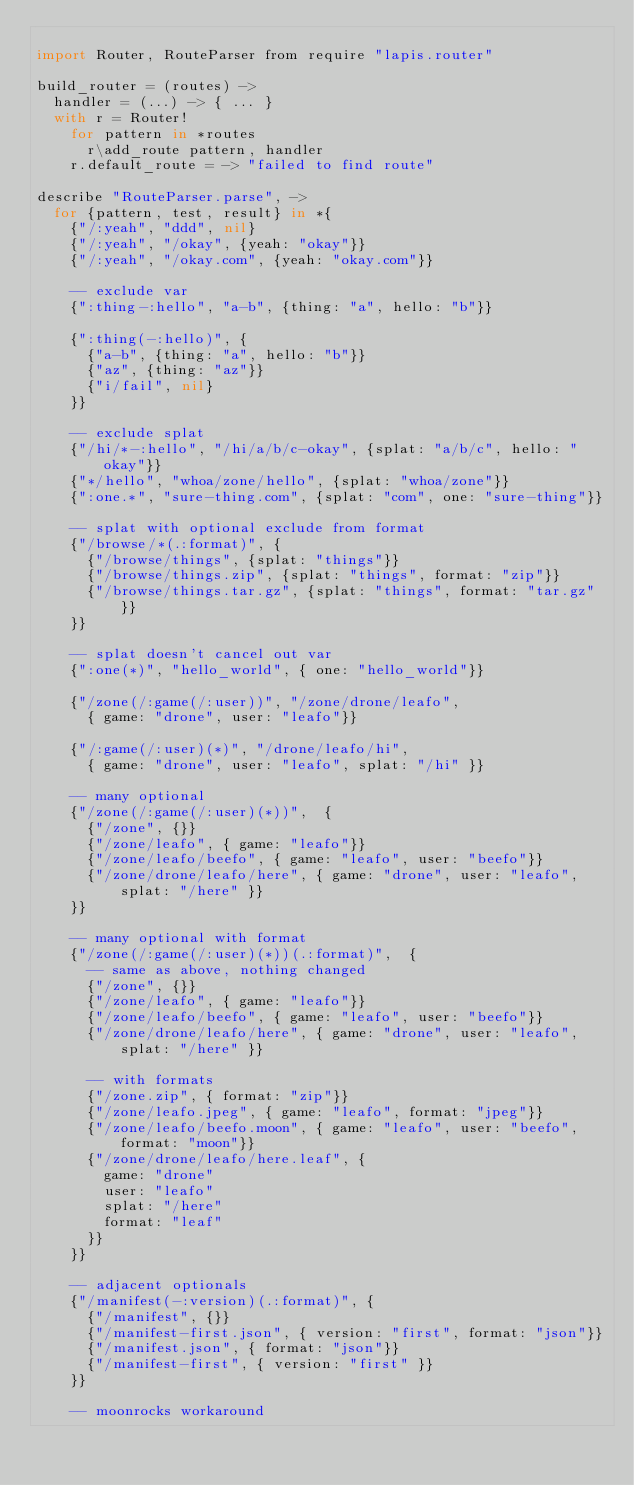Convert code to text. <code><loc_0><loc_0><loc_500><loc_500><_MoonScript_>
import Router, RouteParser from require "lapis.router"

build_router = (routes) ->
  handler = (...) -> { ... }
  with r = Router!
    for pattern in *routes
      r\add_route pattern, handler
    r.default_route = -> "failed to find route"

describe "RouteParser.parse", ->
  for {pattern, test, result} in *{
    {"/:yeah", "ddd", nil}
    {"/:yeah", "/okay", {yeah: "okay"}}
    {"/:yeah", "/okay.com", {yeah: "okay.com"}}

    -- exclude var
    {":thing-:hello", "a-b", {thing: "a", hello: "b"}}

    {":thing(-:hello)", {
      {"a-b", {thing: "a", hello: "b"}}
      {"az", {thing: "az"}}
      {"i/fail", nil}
    }}

    -- exclude splat
    {"/hi/*-:hello", "/hi/a/b/c-okay", {splat: "a/b/c", hello: "okay"}}
    {"*/hello", "whoa/zone/hello", {splat: "whoa/zone"}}
    {":one.*", "sure-thing.com", {splat: "com", one: "sure-thing"}}

    -- splat with optional exclude from format
    {"/browse/*(.:format)", {
      {"/browse/things", {splat: "things"}}
      {"/browse/things.zip", {splat: "things", format: "zip"}}
      {"/browse/things.tar.gz", {splat: "things", format: "tar.gz"}}
    }}

    -- splat doesn't cancel out var
    {":one(*)", "hello_world", { one: "hello_world"}}

    {"/zone(/:game(/:user))", "/zone/drone/leafo",
      { game: "drone", user: "leafo"}}

    {"/:game(/:user)(*)", "/drone/leafo/hi",
      { game: "drone", user: "leafo", splat: "/hi" }}

    -- many optional
    {"/zone(/:game(/:user)(*))",  {
      {"/zone", {}}
      {"/zone/leafo", { game: "leafo"}}
      {"/zone/leafo/beefo", { game: "leafo", user: "beefo"}}
      {"/zone/drone/leafo/here", { game: "drone", user: "leafo", splat: "/here" }}
    }}

    -- many optional with format
    {"/zone(/:game(/:user)(*))(.:format)",  {
      -- same as above, nothing changed
      {"/zone", {}}
      {"/zone/leafo", { game: "leafo"}}
      {"/zone/leafo/beefo", { game: "leafo", user: "beefo"}}
      {"/zone/drone/leafo/here", { game: "drone", user: "leafo", splat: "/here" }}

      -- with formats
      {"/zone.zip", { format: "zip"}}
      {"/zone/leafo.jpeg", { game: "leafo", format: "jpeg"}}
      {"/zone/leafo/beefo.moon", { game: "leafo", user: "beefo", format: "moon"}}
      {"/zone/drone/leafo/here.leaf", {
        game: "drone"
        user: "leafo"
        splat: "/here"
        format: "leaf"
      }}
    }}

    -- adjacent optionals
    {"/manifest(-:version)(.:format)", {
      {"/manifest", {}}
      {"/manifest-first.json", { version: "first", format: "json"}}
      {"/manifest.json", { format: "json"}}
      {"/manifest-first", { version: "first" }}
    }}

    -- moonrocks workaround</code> 